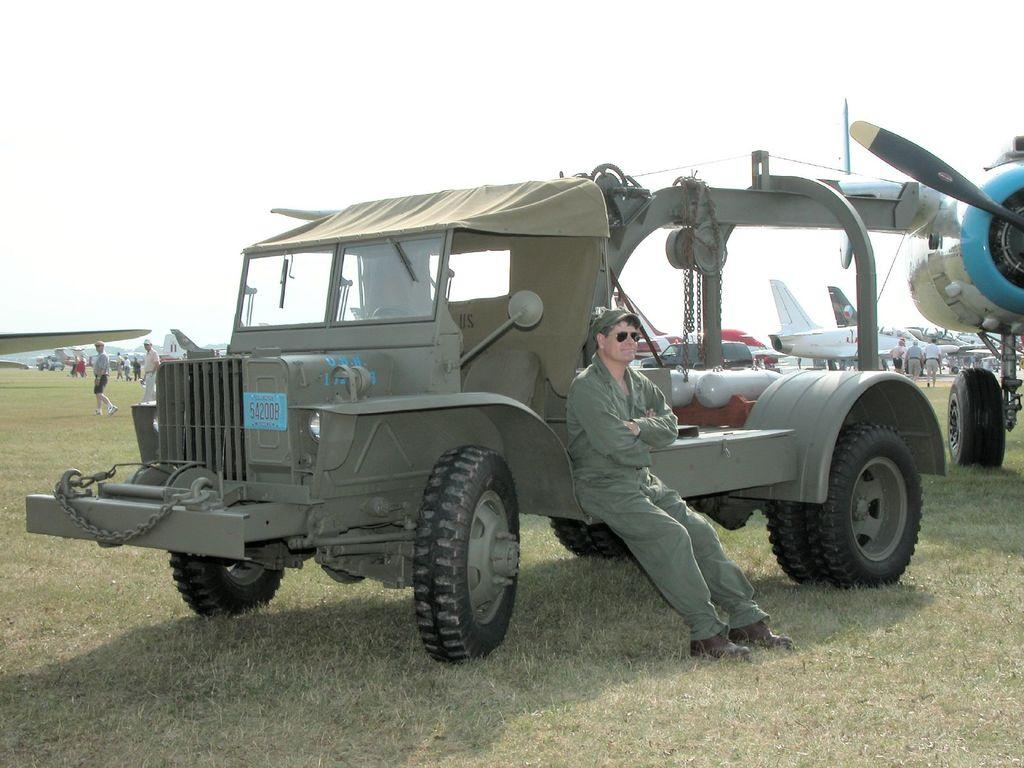What is the person in the image wearing? The person in the image is wearing a green dress. What is the person doing in the image? The person is sitting on a vehicle. Where is the vehicle located in the image? The vehicle is on the grass on the ground. What can be seen in the background of the image? There are aircraft, persons on the ground, and the sky visible in the background of the image. How many dogs are present in the image? There are no dogs present in the image. 